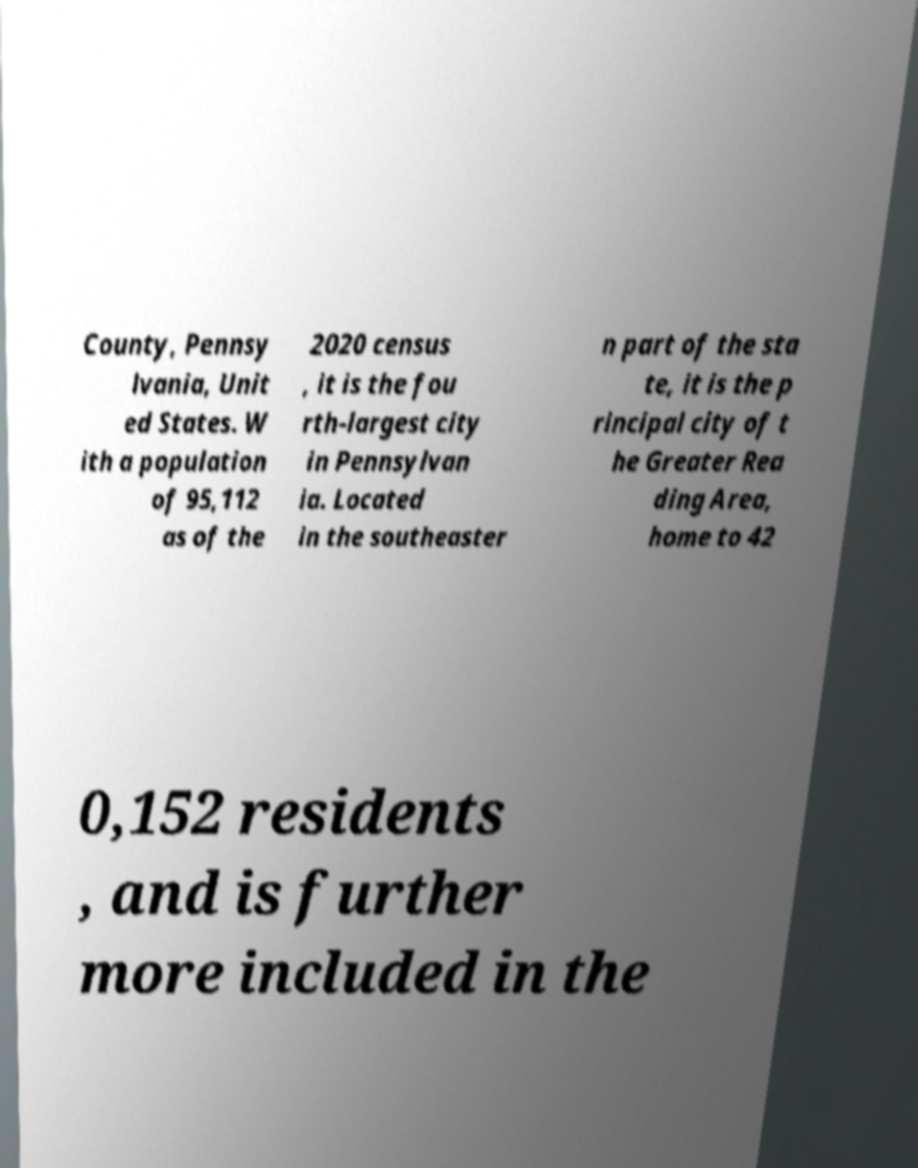Can you read and provide the text displayed in the image?This photo seems to have some interesting text. Can you extract and type it out for me? County, Pennsy lvania, Unit ed States. W ith a population of 95,112 as of the 2020 census , it is the fou rth-largest city in Pennsylvan ia. Located in the southeaster n part of the sta te, it is the p rincipal city of t he Greater Rea ding Area, home to 42 0,152 residents , and is further more included in the 